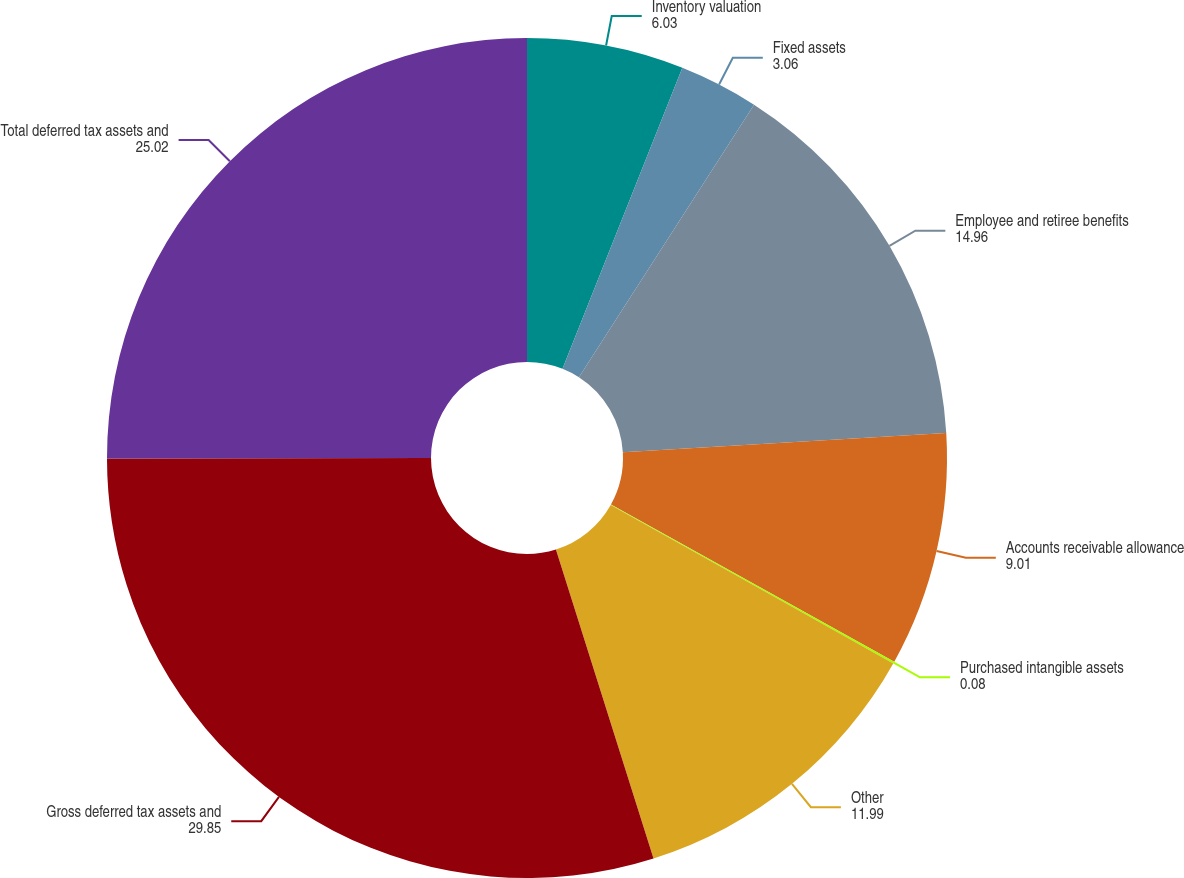<chart> <loc_0><loc_0><loc_500><loc_500><pie_chart><fcel>Inventory valuation<fcel>Fixed assets<fcel>Employee and retiree benefits<fcel>Accounts receivable allowance<fcel>Purchased intangible assets<fcel>Other<fcel>Gross deferred tax assets and<fcel>Total deferred tax assets and<nl><fcel>6.03%<fcel>3.06%<fcel>14.96%<fcel>9.01%<fcel>0.08%<fcel>11.99%<fcel>29.85%<fcel>25.02%<nl></chart> 